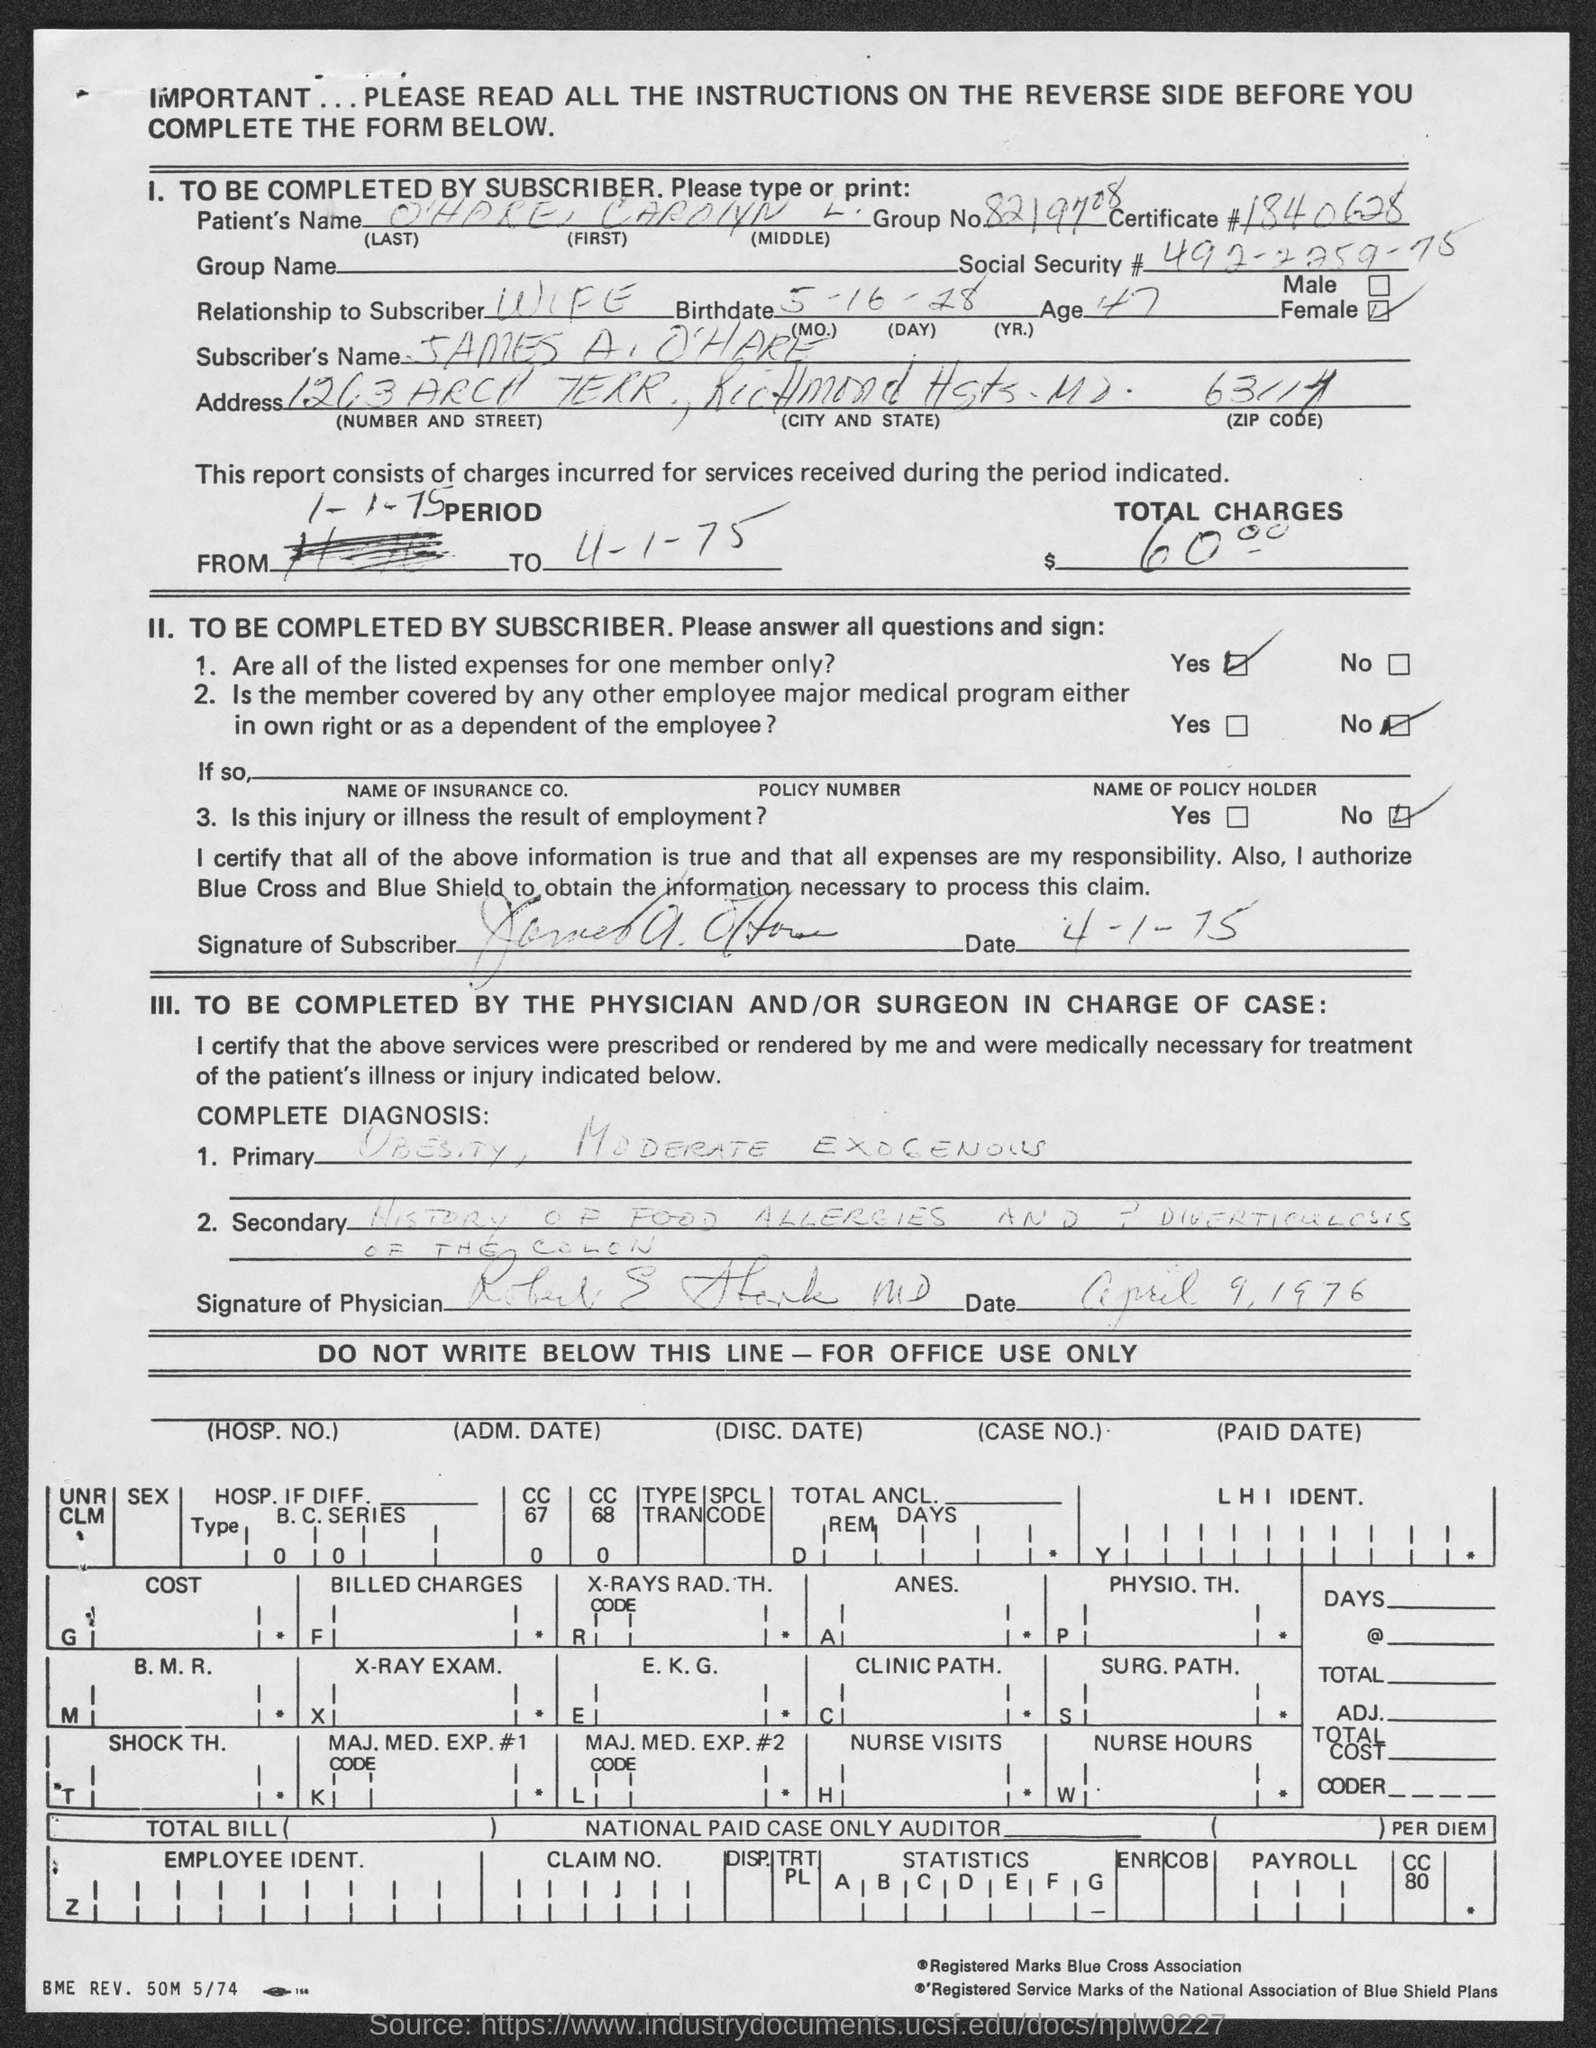What is the group no. ?
Your answer should be very brief. 8219708. What is the patient's name?
Your response must be concise. O'hare  Carolyn L. What is the certificate #?
Give a very brief answer. 1840628. What is social security #?
Provide a succinct answer. 492-2759-75. What is the relation to the subscriber ?
Provide a succinct answer. Wife. What is the subscriber's name ?
Provide a succinct answer. James A. O'hare. 